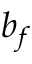<formula> <loc_0><loc_0><loc_500><loc_500>b _ { f }</formula> 